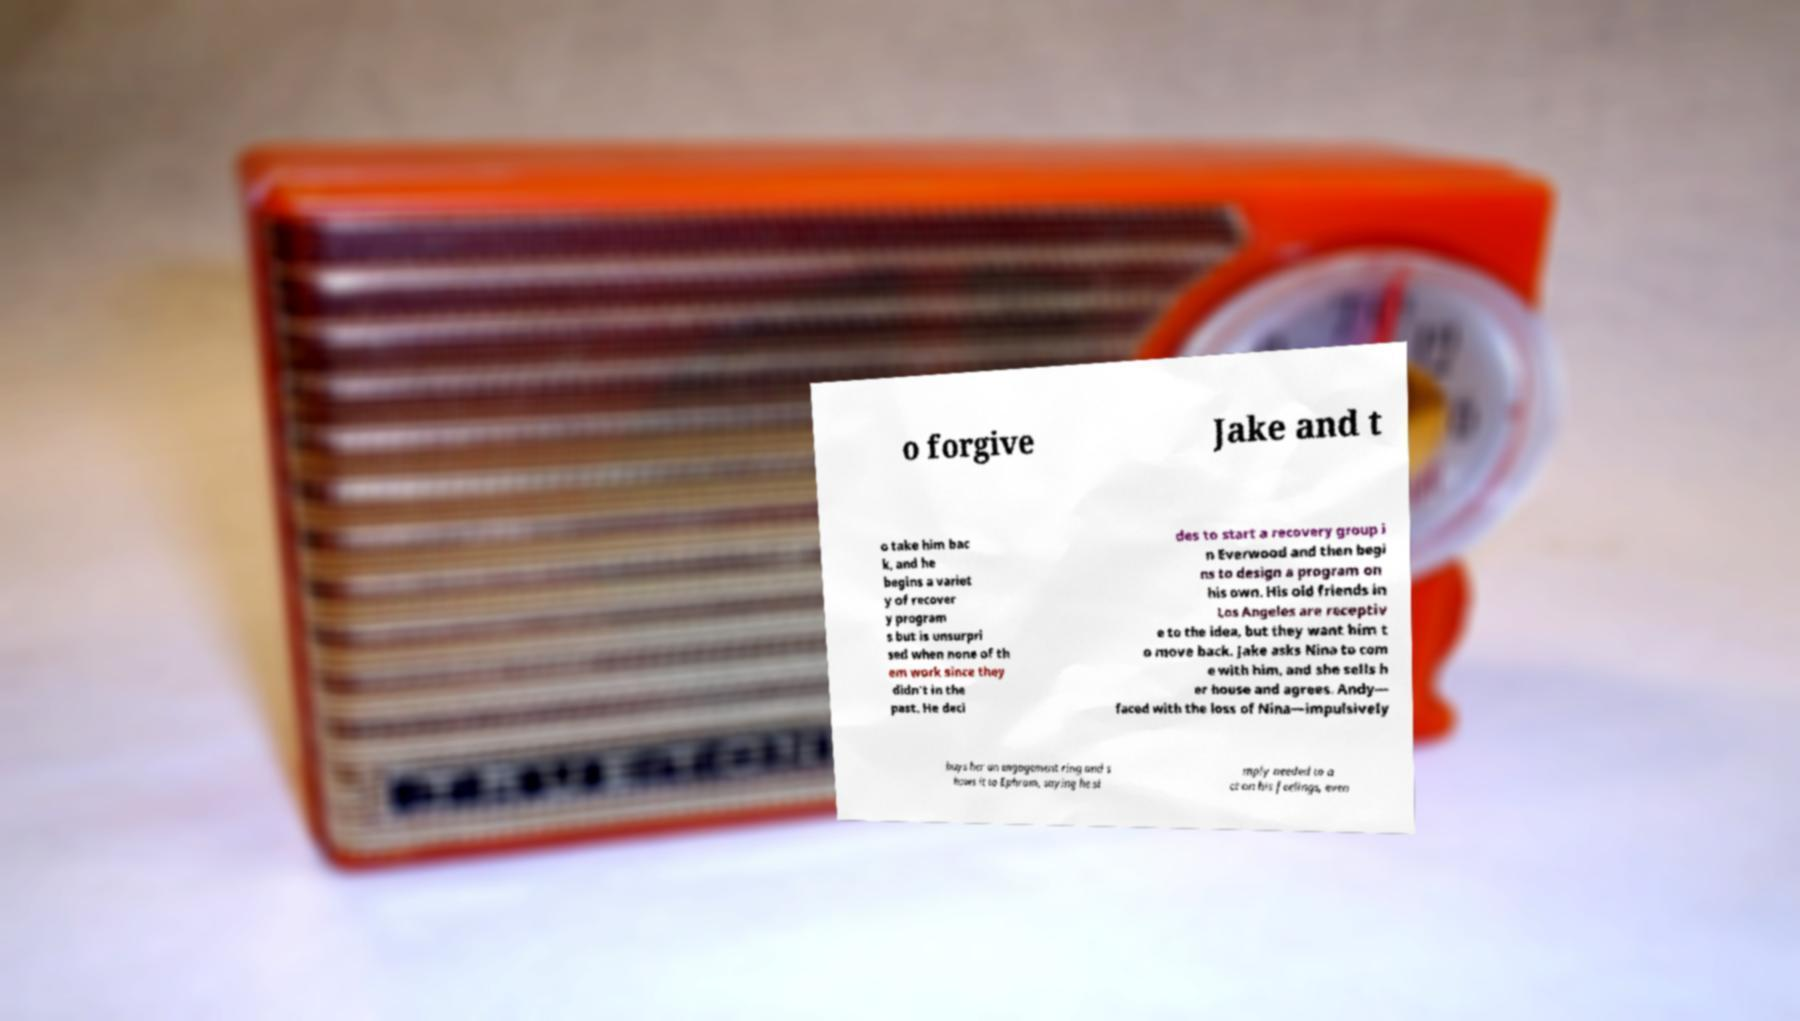Could you assist in decoding the text presented in this image and type it out clearly? o forgive Jake and t o take him bac k, and he begins a variet y of recover y program s but is unsurpri sed when none of th em work since they didn't in the past. He deci des to start a recovery group i n Everwood and then begi ns to design a program on his own. His old friends in Los Angeles are receptiv e to the idea, but they want him t o move back. Jake asks Nina to com e with him, and she sells h er house and agrees. Andy— faced with the loss of Nina—impulsively buys her an engagement ring and s hows it to Ephram, saying he si mply needed to a ct on his feelings, even 